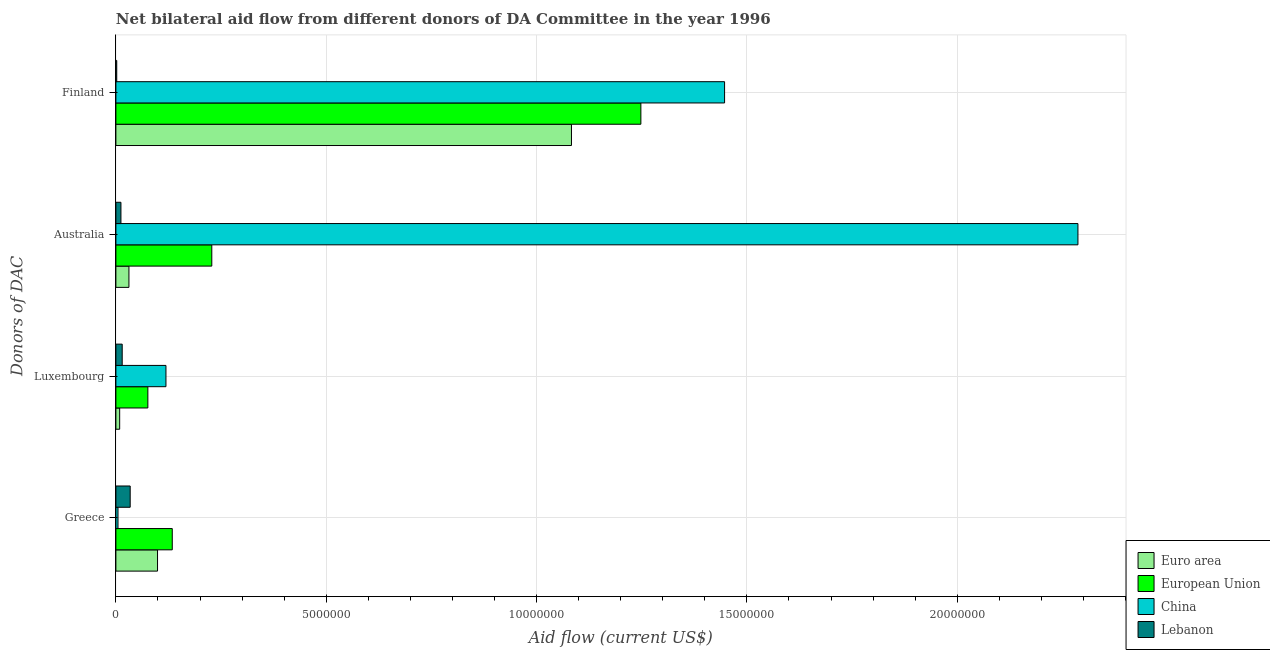How many different coloured bars are there?
Provide a succinct answer. 4. Are the number of bars on each tick of the Y-axis equal?
Provide a short and direct response. Yes. How many bars are there on the 1st tick from the top?
Make the answer very short. 4. What is the label of the 1st group of bars from the top?
Offer a terse response. Finland. What is the amount of aid given by finland in China?
Provide a short and direct response. 1.45e+07. Across all countries, what is the maximum amount of aid given by finland?
Give a very brief answer. 1.45e+07. Across all countries, what is the minimum amount of aid given by greece?
Provide a succinct answer. 5.00e+04. In which country was the amount of aid given by australia maximum?
Ensure brevity in your answer.  China. In which country was the amount of aid given by australia minimum?
Provide a succinct answer. Lebanon. What is the total amount of aid given by greece in the graph?
Give a very brief answer. 2.72e+06. What is the difference between the amount of aid given by finland in China and that in European Union?
Your answer should be very brief. 1.99e+06. What is the difference between the amount of aid given by luxembourg in China and the amount of aid given by finland in Lebanon?
Provide a succinct answer. 1.17e+06. What is the average amount of aid given by luxembourg per country?
Your response must be concise. 5.48e+05. What is the difference between the amount of aid given by greece and amount of aid given by finland in Euro area?
Keep it short and to the point. -9.84e+06. What is the ratio of the amount of aid given by finland in Lebanon to that in European Union?
Ensure brevity in your answer.  0. What is the difference between the highest and the second highest amount of aid given by finland?
Your answer should be very brief. 1.99e+06. What is the difference between the highest and the lowest amount of aid given by greece?
Provide a succinct answer. 1.29e+06. In how many countries, is the amount of aid given by luxembourg greater than the average amount of aid given by luxembourg taken over all countries?
Give a very brief answer. 2. Is the sum of the amount of aid given by greece in Euro area and China greater than the maximum amount of aid given by australia across all countries?
Offer a very short reply. No. Is it the case that in every country, the sum of the amount of aid given by greece and amount of aid given by australia is greater than the sum of amount of aid given by finland and amount of aid given by luxembourg?
Your response must be concise. No. What does the 4th bar from the bottom in Finland represents?
Keep it short and to the point. Lebanon. How many bars are there?
Offer a terse response. 16. Are all the bars in the graph horizontal?
Provide a succinct answer. Yes. What is the difference between two consecutive major ticks on the X-axis?
Your answer should be very brief. 5.00e+06. Are the values on the major ticks of X-axis written in scientific E-notation?
Provide a succinct answer. No. Does the graph contain any zero values?
Provide a short and direct response. No. Does the graph contain grids?
Provide a short and direct response. Yes. How many legend labels are there?
Offer a very short reply. 4. How are the legend labels stacked?
Your answer should be compact. Vertical. What is the title of the graph?
Provide a short and direct response. Net bilateral aid flow from different donors of DA Committee in the year 1996. What is the label or title of the X-axis?
Offer a terse response. Aid flow (current US$). What is the label or title of the Y-axis?
Your response must be concise. Donors of DAC. What is the Aid flow (current US$) of Euro area in Greece?
Give a very brief answer. 9.90e+05. What is the Aid flow (current US$) of European Union in Greece?
Keep it short and to the point. 1.34e+06. What is the Aid flow (current US$) of China in Greece?
Your response must be concise. 5.00e+04. What is the Aid flow (current US$) in Lebanon in Greece?
Provide a short and direct response. 3.40e+05. What is the Aid flow (current US$) in Euro area in Luxembourg?
Give a very brief answer. 9.00e+04. What is the Aid flow (current US$) in European Union in Luxembourg?
Provide a succinct answer. 7.60e+05. What is the Aid flow (current US$) of China in Luxembourg?
Offer a very short reply. 1.19e+06. What is the Aid flow (current US$) in European Union in Australia?
Offer a terse response. 2.28e+06. What is the Aid flow (current US$) in China in Australia?
Your answer should be very brief. 2.29e+07. What is the Aid flow (current US$) in Lebanon in Australia?
Your answer should be very brief. 1.20e+05. What is the Aid flow (current US$) of Euro area in Finland?
Provide a succinct answer. 1.08e+07. What is the Aid flow (current US$) in European Union in Finland?
Your response must be concise. 1.25e+07. What is the Aid flow (current US$) in China in Finland?
Your response must be concise. 1.45e+07. What is the Aid flow (current US$) in Lebanon in Finland?
Your answer should be compact. 2.00e+04. Across all Donors of DAC, what is the maximum Aid flow (current US$) in Euro area?
Give a very brief answer. 1.08e+07. Across all Donors of DAC, what is the maximum Aid flow (current US$) in European Union?
Ensure brevity in your answer.  1.25e+07. Across all Donors of DAC, what is the maximum Aid flow (current US$) of China?
Offer a very short reply. 2.29e+07. Across all Donors of DAC, what is the minimum Aid flow (current US$) in European Union?
Your answer should be compact. 7.60e+05. What is the total Aid flow (current US$) of Euro area in the graph?
Make the answer very short. 1.22e+07. What is the total Aid flow (current US$) of European Union in the graph?
Your answer should be very brief. 1.69e+07. What is the total Aid flow (current US$) in China in the graph?
Your answer should be very brief. 3.86e+07. What is the total Aid flow (current US$) of Lebanon in the graph?
Offer a terse response. 6.30e+05. What is the difference between the Aid flow (current US$) of European Union in Greece and that in Luxembourg?
Provide a short and direct response. 5.80e+05. What is the difference between the Aid flow (current US$) in China in Greece and that in Luxembourg?
Ensure brevity in your answer.  -1.14e+06. What is the difference between the Aid flow (current US$) in Euro area in Greece and that in Australia?
Keep it short and to the point. 6.80e+05. What is the difference between the Aid flow (current US$) in European Union in Greece and that in Australia?
Make the answer very short. -9.40e+05. What is the difference between the Aid flow (current US$) of China in Greece and that in Australia?
Ensure brevity in your answer.  -2.28e+07. What is the difference between the Aid flow (current US$) of Lebanon in Greece and that in Australia?
Your response must be concise. 2.20e+05. What is the difference between the Aid flow (current US$) of Euro area in Greece and that in Finland?
Ensure brevity in your answer.  -9.84e+06. What is the difference between the Aid flow (current US$) in European Union in Greece and that in Finland?
Give a very brief answer. -1.11e+07. What is the difference between the Aid flow (current US$) of China in Greece and that in Finland?
Give a very brief answer. -1.44e+07. What is the difference between the Aid flow (current US$) in Lebanon in Greece and that in Finland?
Provide a succinct answer. 3.20e+05. What is the difference between the Aid flow (current US$) of European Union in Luxembourg and that in Australia?
Offer a terse response. -1.52e+06. What is the difference between the Aid flow (current US$) in China in Luxembourg and that in Australia?
Give a very brief answer. -2.17e+07. What is the difference between the Aid flow (current US$) in Lebanon in Luxembourg and that in Australia?
Give a very brief answer. 3.00e+04. What is the difference between the Aid flow (current US$) in Euro area in Luxembourg and that in Finland?
Provide a short and direct response. -1.07e+07. What is the difference between the Aid flow (current US$) of European Union in Luxembourg and that in Finland?
Your answer should be very brief. -1.17e+07. What is the difference between the Aid flow (current US$) in China in Luxembourg and that in Finland?
Provide a short and direct response. -1.33e+07. What is the difference between the Aid flow (current US$) in Euro area in Australia and that in Finland?
Your answer should be very brief. -1.05e+07. What is the difference between the Aid flow (current US$) of European Union in Australia and that in Finland?
Offer a very short reply. -1.02e+07. What is the difference between the Aid flow (current US$) of China in Australia and that in Finland?
Your answer should be very brief. 8.40e+06. What is the difference between the Aid flow (current US$) in Lebanon in Australia and that in Finland?
Ensure brevity in your answer.  1.00e+05. What is the difference between the Aid flow (current US$) in Euro area in Greece and the Aid flow (current US$) in European Union in Luxembourg?
Provide a short and direct response. 2.30e+05. What is the difference between the Aid flow (current US$) of Euro area in Greece and the Aid flow (current US$) of China in Luxembourg?
Give a very brief answer. -2.00e+05. What is the difference between the Aid flow (current US$) in Euro area in Greece and the Aid flow (current US$) in Lebanon in Luxembourg?
Give a very brief answer. 8.40e+05. What is the difference between the Aid flow (current US$) in European Union in Greece and the Aid flow (current US$) in Lebanon in Luxembourg?
Your response must be concise. 1.19e+06. What is the difference between the Aid flow (current US$) in Euro area in Greece and the Aid flow (current US$) in European Union in Australia?
Keep it short and to the point. -1.29e+06. What is the difference between the Aid flow (current US$) of Euro area in Greece and the Aid flow (current US$) of China in Australia?
Ensure brevity in your answer.  -2.19e+07. What is the difference between the Aid flow (current US$) of Euro area in Greece and the Aid flow (current US$) of Lebanon in Australia?
Make the answer very short. 8.70e+05. What is the difference between the Aid flow (current US$) of European Union in Greece and the Aid flow (current US$) of China in Australia?
Make the answer very short. -2.15e+07. What is the difference between the Aid flow (current US$) of European Union in Greece and the Aid flow (current US$) of Lebanon in Australia?
Offer a very short reply. 1.22e+06. What is the difference between the Aid flow (current US$) of China in Greece and the Aid flow (current US$) of Lebanon in Australia?
Offer a very short reply. -7.00e+04. What is the difference between the Aid flow (current US$) in Euro area in Greece and the Aid flow (current US$) in European Union in Finland?
Your response must be concise. -1.15e+07. What is the difference between the Aid flow (current US$) of Euro area in Greece and the Aid flow (current US$) of China in Finland?
Offer a very short reply. -1.35e+07. What is the difference between the Aid flow (current US$) of Euro area in Greece and the Aid flow (current US$) of Lebanon in Finland?
Offer a very short reply. 9.70e+05. What is the difference between the Aid flow (current US$) of European Union in Greece and the Aid flow (current US$) of China in Finland?
Offer a terse response. -1.31e+07. What is the difference between the Aid flow (current US$) of European Union in Greece and the Aid flow (current US$) of Lebanon in Finland?
Offer a very short reply. 1.32e+06. What is the difference between the Aid flow (current US$) in Euro area in Luxembourg and the Aid flow (current US$) in European Union in Australia?
Provide a short and direct response. -2.19e+06. What is the difference between the Aid flow (current US$) of Euro area in Luxembourg and the Aid flow (current US$) of China in Australia?
Ensure brevity in your answer.  -2.28e+07. What is the difference between the Aid flow (current US$) of European Union in Luxembourg and the Aid flow (current US$) of China in Australia?
Provide a succinct answer. -2.21e+07. What is the difference between the Aid flow (current US$) in European Union in Luxembourg and the Aid flow (current US$) in Lebanon in Australia?
Your answer should be very brief. 6.40e+05. What is the difference between the Aid flow (current US$) in China in Luxembourg and the Aid flow (current US$) in Lebanon in Australia?
Offer a terse response. 1.07e+06. What is the difference between the Aid flow (current US$) of Euro area in Luxembourg and the Aid flow (current US$) of European Union in Finland?
Your response must be concise. -1.24e+07. What is the difference between the Aid flow (current US$) of Euro area in Luxembourg and the Aid flow (current US$) of China in Finland?
Provide a succinct answer. -1.44e+07. What is the difference between the Aid flow (current US$) in European Union in Luxembourg and the Aid flow (current US$) in China in Finland?
Keep it short and to the point. -1.37e+07. What is the difference between the Aid flow (current US$) in European Union in Luxembourg and the Aid flow (current US$) in Lebanon in Finland?
Give a very brief answer. 7.40e+05. What is the difference between the Aid flow (current US$) of China in Luxembourg and the Aid flow (current US$) of Lebanon in Finland?
Make the answer very short. 1.17e+06. What is the difference between the Aid flow (current US$) of Euro area in Australia and the Aid flow (current US$) of European Union in Finland?
Ensure brevity in your answer.  -1.22e+07. What is the difference between the Aid flow (current US$) in Euro area in Australia and the Aid flow (current US$) in China in Finland?
Your answer should be compact. -1.42e+07. What is the difference between the Aid flow (current US$) of European Union in Australia and the Aid flow (current US$) of China in Finland?
Keep it short and to the point. -1.22e+07. What is the difference between the Aid flow (current US$) of European Union in Australia and the Aid flow (current US$) of Lebanon in Finland?
Give a very brief answer. 2.26e+06. What is the difference between the Aid flow (current US$) of China in Australia and the Aid flow (current US$) of Lebanon in Finland?
Offer a very short reply. 2.28e+07. What is the average Aid flow (current US$) of Euro area per Donors of DAC?
Provide a short and direct response. 3.06e+06. What is the average Aid flow (current US$) in European Union per Donors of DAC?
Your response must be concise. 4.22e+06. What is the average Aid flow (current US$) in China per Donors of DAC?
Make the answer very short. 9.64e+06. What is the average Aid flow (current US$) in Lebanon per Donors of DAC?
Offer a terse response. 1.58e+05. What is the difference between the Aid flow (current US$) in Euro area and Aid flow (current US$) in European Union in Greece?
Give a very brief answer. -3.50e+05. What is the difference between the Aid flow (current US$) of Euro area and Aid flow (current US$) of China in Greece?
Keep it short and to the point. 9.40e+05. What is the difference between the Aid flow (current US$) of Euro area and Aid flow (current US$) of Lebanon in Greece?
Your answer should be very brief. 6.50e+05. What is the difference between the Aid flow (current US$) in European Union and Aid flow (current US$) in China in Greece?
Provide a short and direct response. 1.29e+06. What is the difference between the Aid flow (current US$) in Euro area and Aid flow (current US$) in European Union in Luxembourg?
Make the answer very short. -6.70e+05. What is the difference between the Aid flow (current US$) in Euro area and Aid flow (current US$) in China in Luxembourg?
Provide a short and direct response. -1.10e+06. What is the difference between the Aid flow (current US$) in Euro area and Aid flow (current US$) in Lebanon in Luxembourg?
Your answer should be compact. -6.00e+04. What is the difference between the Aid flow (current US$) of European Union and Aid flow (current US$) of China in Luxembourg?
Give a very brief answer. -4.30e+05. What is the difference between the Aid flow (current US$) in China and Aid flow (current US$) in Lebanon in Luxembourg?
Give a very brief answer. 1.04e+06. What is the difference between the Aid flow (current US$) of Euro area and Aid flow (current US$) of European Union in Australia?
Your answer should be very brief. -1.97e+06. What is the difference between the Aid flow (current US$) of Euro area and Aid flow (current US$) of China in Australia?
Your answer should be compact. -2.26e+07. What is the difference between the Aid flow (current US$) in Euro area and Aid flow (current US$) in Lebanon in Australia?
Your answer should be compact. 1.90e+05. What is the difference between the Aid flow (current US$) of European Union and Aid flow (current US$) of China in Australia?
Offer a very short reply. -2.06e+07. What is the difference between the Aid flow (current US$) of European Union and Aid flow (current US$) of Lebanon in Australia?
Provide a succinct answer. 2.16e+06. What is the difference between the Aid flow (current US$) of China and Aid flow (current US$) of Lebanon in Australia?
Provide a succinct answer. 2.28e+07. What is the difference between the Aid flow (current US$) of Euro area and Aid flow (current US$) of European Union in Finland?
Provide a short and direct response. -1.65e+06. What is the difference between the Aid flow (current US$) of Euro area and Aid flow (current US$) of China in Finland?
Keep it short and to the point. -3.64e+06. What is the difference between the Aid flow (current US$) of Euro area and Aid flow (current US$) of Lebanon in Finland?
Offer a terse response. 1.08e+07. What is the difference between the Aid flow (current US$) of European Union and Aid flow (current US$) of China in Finland?
Give a very brief answer. -1.99e+06. What is the difference between the Aid flow (current US$) of European Union and Aid flow (current US$) of Lebanon in Finland?
Keep it short and to the point. 1.25e+07. What is the difference between the Aid flow (current US$) in China and Aid flow (current US$) in Lebanon in Finland?
Provide a succinct answer. 1.44e+07. What is the ratio of the Aid flow (current US$) of Euro area in Greece to that in Luxembourg?
Give a very brief answer. 11. What is the ratio of the Aid flow (current US$) of European Union in Greece to that in Luxembourg?
Keep it short and to the point. 1.76. What is the ratio of the Aid flow (current US$) of China in Greece to that in Luxembourg?
Keep it short and to the point. 0.04. What is the ratio of the Aid flow (current US$) of Lebanon in Greece to that in Luxembourg?
Your answer should be very brief. 2.27. What is the ratio of the Aid flow (current US$) in Euro area in Greece to that in Australia?
Offer a terse response. 3.19. What is the ratio of the Aid flow (current US$) of European Union in Greece to that in Australia?
Your answer should be very brief. 0.59. What is the ratio of the Aid flow (current US$) in China in Greece to that in Australia?
Provide a succinct answer. 0. What is the ratio of the Aid flow (current US$) of Lebanon in Greece to that in Australia?
Your answer should be very brief. 2.83. What is the ratio of the Aid flow (current US$) of Euro area in Greece to that in Finland?
Offer a very short reply. 0.09. What is the ratio of the Aid flow (current US$) in European Union in Greece to that in Finland?
Your answer should be very brief. 0.11. What is the ratio of the Aid flow (current US$) of China in Greece to that in Finland?
Give a very brief answer. 0. What is the ratio of the Aid flow (current US$) of Euro area in Luxembourg to that in Australia?
Keep it short and to the point. 0.29. What is the ratio of the Aid flow (current US$) of China in Luxembourg to that in Australia?
Ensure brevity in your answer.  0.05. What is the ratio of the Aid flow (current US$) in Euro area in Luxembourg to that in Finland?
Provide a short and direct response. 0.01. What is the ratio of the Aid flow (current US$) in European Union in Luxembourg to that in Finland?
Keep it short and to the point. 0.06. What is the ratio of the Aid flow (current US$) in China in Luxembourg to that in Finland?
Keep it short and to the point. 0.08. What is the ratio of the Aid flow (current US$) of Lebanon in Luxembourg to that in Finland?
Make the answer very short. 7.5. What is the ratio of the Aid flow (current US$) in Euro area in Australia to that in Finland?
Keep it short and to the point. 0.03. What is the ratio of the Aid flow (current US$) in European Union in Australia to that in Finland?
Provide a short and direct response. 0.18. What is the ratio of the Aid flow (current US$) of China in Australia to that in Finland?
Provide a succinct answer. 1.58. What is the difference between the highest and the second highest Aid flow (current US$) in Euro area?
Your answer should be compact. 9.84e+06. What is the difference between the highest and the second highest Aid flow (current US$) of European Union?
Provide a short and direct response. 1.02e+07. What is the difference between the highest and the second highest Aid flow (current US$) in China?
Make the answer very short. 8.40e+06. What is the difference between the highest and the lowest Aid flow (current US$) of Euro area?
Offer a terse response. 1.07e+07. What is the difference between the highest and the lowest Aid flow (current US$) of European Union?
Provide a succinct answer. 1.17e+07. What is the difference between the highest and the lowest Aid flow (current US$) in China?
Offer a very short reply. 2.28e+07. What is the difference between the highest and the lowest Aid flow (current US$) of Lebanon?
Provide a succinct answer. 3.20e+05. 